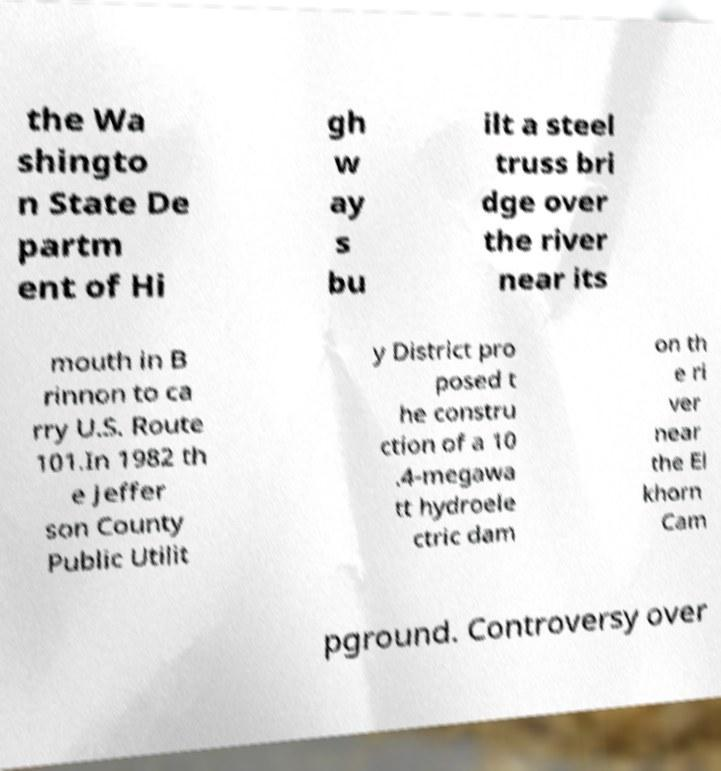What messages or text are displayed in this image? I need them in a readable, typed format. the Wa shingto n State De partm ent of Hi gh w ay s bu ilt a steel truss bri dge over the river near its mouth in B rinnon to ca rry U.S. Route 101.In 1982 th e Jeffer son County Public Utilit y District pro posed t he constru ction of a 10 .4-megawa tt hydroele ctric dam on th e ri ver near the El khorn Cam pground. Controversy over 